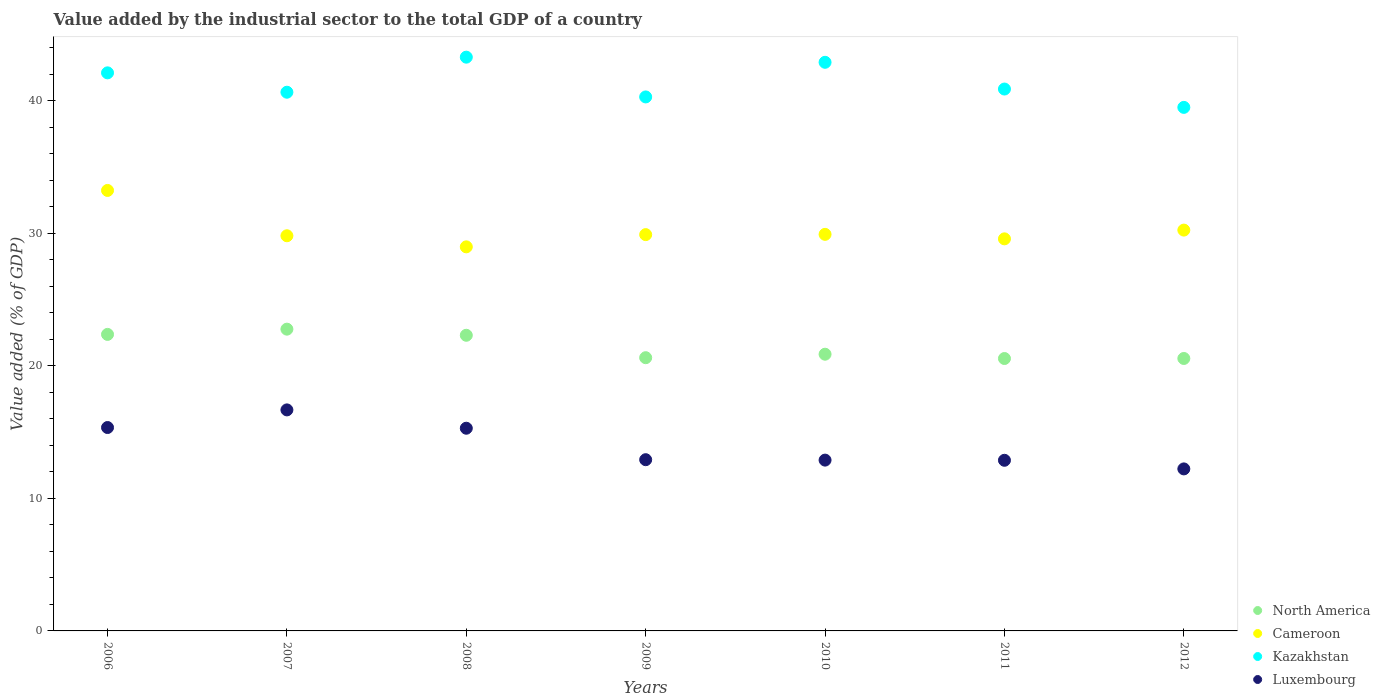How many different coloured dotlines are there?
Offer a very short reply. 4. What is the value added by the industrial sector to the total GDP in North America in 2011?
Your answer should be compact. 20.55. Across all years, what is the maximum value added by the industrial sector to the total GDP in North America?
Your answer should be compact. 22.76. Across all years, what is the minimum value added by the industrial sector to the total GDP in Kazakhstan?
Provide a succinct answer. 39.5. What is the total value added by the industrial sector to the total GDP in Luxembourg in the graph?
Offer a terse response. 98.21. What is the difference between the value added by the industrial sector to the total GDP in Cameroon in 2006 and that in 2009?
Provide a succinct answer. 3.33. What is the difference between the value added by the industrial sector to the total GDP in Cameroon in 2010 and the value added by the industrial sector to the total GDP in North America in 2012?
Your answer should be compact. 9.36. What is the average value added by the industrial sector to the total GDP in Cameroon per year?
Offer a terse response. 30.23. In the year 2009, what is the difference between the value added by the industrial sector to the total GDP in Luxembourg and value added by the industrial sector to the total GDP in North America?
Offer a terse response. -7.69. In how many years, is the value added by the industrial sector to the total GDP in Cameroon greater than 22 %?
Offer a terse response. 7. What is the ratio of the value added by the industrial sector to the total GDP in Kazakhstan in 2009 to that in 2011?
Your answer should be very brief. 0.99. Is the value added by the industrial sector to the total GDP in North America in 2010 less than that in 2012?
Offer a terse response. No. What is the difference between the highest and the second highest value added by the industrial sector to the total GDP in North America?
Provide a short and direct response. 0.4. What is the difference between the highest and the lowest value added by the industrial sector to the total GDP in Kazakhstan?
Provide a short and direct response. 3.79. In how many years, is the value added by the industrial sector to the total GDP in Kazakhstan greater than the average value added by the industrial sector to the total GDP in Kazakhstan taken over all years?
Ensure brevity in your answer.  3. Is the sum of the value added by the industrial sector to the total GDP in Luxembourg in 2008 and 2011 greater than the maximum value added by the industrial sector to the total GDP in Kazakhstan across all years?
Offer a terse response. No. Is the value added by the industrial sector to the total GDP in North America strictly less than the value added by the industrial sector to the total GDP in Cameroon over the years?
Keep it short and to the point. Yes. What is the difference between two consecutive major ticks on the Y-axis?
Offer a terse response. 10. Does the graph contain any zero values?
Keep it short and to the point. No. Does the graph contain grids?
Ensure brevity in your answer.  No. How many legend labels are there?
Your answer should be compact. 4. How are the legend labels stacked?
Ensure brevity in your answer.  Vertical. What is the title of the graph?
Your answer should be very brief. Value added by the industrial sector to the total GDP of a country. What is the label or title of the X-axis?
Keep it short and to the point. Years. What is the label or title of the Y-axis?
Make the answer very short. Value added (% of GDP). What is the Value added (% of GDP) of North America in 2006?
Make the answer very short. 22.37. What is the Value added (% of GDP) in Cameroon in 2006?
Your answer should be very brief. 33.23. What is the Value added (% of GDP) in Kazakhstan in 2006?
Provide a succinct answer. 42.1. What is the Value added (% of GDP) in Luxembourg in 2006?
Ensure brevity in your answer.  15.34. What is the Value added (% of GDP) in North America in 2007?
Your answer should be compact. 22.76. What is the Value added (% of GDP) of Cameroon in 2007?
Give a very brief answer. 29.81. What is the Value added (% of GDP) of Kazakhstan in 2007?
Keep it short and to the point. 40.64. What is the Value added (% of GDP) of Luxembourg in 2007?
Your answer should be very brief. 16.67. What is the Value added (% of GDP) in North America in 2008?
Provide a short and direct response. 22.3. What is the Value added (% of GDP) in Cameroon in 2008?
Your response must be concise. 28.97. What is the Value added (% of GDP) of Kazakhstan in 2008?
Provide a succinct answer. 43.28. What is the Value added (% of GDP) in Luxembourg in 2008?
Make the answer very short. 15.29. What is the Value added (% of GDP) of North America in 2009?
Offer a very short reply. 20.61. What is the Value added (% of GDP) of Cameroon in 2009?
Offer a very short reply. 29.9. What is the Value added (% of GDP) of Kazakhstan in 2009?
Offer a very short reply. 40.28. What is the Value added (% of GDP) in Luxembourg in 2009?
Offer a terse response. 12.92. What is the Value added (% of GDP) of North America in 2010?
Your answer should be very brief. 20.88. What is the Value added (% of GDP) in Cameroon in 2010?
Offer a very short reply. 29.92. What is the Value added (% of GDP) of Kazakhstan in 2010?
Your response must be concise. 42.9. What is the Value added (% of GDP) in Luxembourg in 2010?
Keep it short and to the point. 12.89. What is the Value added (% of GDP) of North America in 2011?
Provide a short and direct response. 20.55. What is the Value added (% of GDP) of Cameroon in 2011?
Your answer should be very brief. 29.58. What is the Value added (% of GDP) of Kazakhstan in 2011?
Your answer should be very brief. 40.88. What is the Value added (% of GDP) in Luxembourg in 2011?
Keep it short and to the point. 12.87. What is the Value added (% of GDP) in North America in 2012?
Ensure brevity in your answer.  20.55. What is the Value added (% of GDP) of Cameroon in 2012?
Provide a short and direct response. 30.24. What is the Value added (% of GDP) in Kazakhstan in 2012?
Provide a short and direct response. 39.5. What is the Value added (% of GDP) in Luxembourg in 2012?
Make the answer very short. 12.22. Across all years, what is the maximum Value added (% of GDP) of North America?
Offer a terse response. 22.76. Across all years, what is the maximum Value added (% of GDP) of Cameroon?
Ensure brevity in your answer.  33.23. Across all years, what is the maximum Value added (% of GDP) in Kazakhstan?
Ensure brevity in your answer.  43.28. Across all years, what is the maximum Value added (% of GDP) of Luxembourg?
Give a very brief answer. 16.67. Across all years, what is the minimum Value added (% of GDP) of North America?
Provide a succinct answer. 20.55. Across all years, what is the minimum Value added (% of GDP) in Cameroon?
Provide a succinct answer. 28.97. Across all years, what is the minimum Value added (% of GDP) in Kazakhstan?
Offer a terse response. 39.5. Across all years, what is the minimum Value added (% of GDP) in Luxembourg?
Your response must be concise. 12.22. What is the total Value added (% of GDP) of North America in the graph?
Your answer should be compact. 150.03. What is the total Value added (% of GDP) of Cameroon in the graph?
Offer a very short reply. 211.64. What is the total Value added (% of GDP) of Kazakhstan in the graph?
Your answer should be very brief. 289.58. What is the total Value added (% of GDP) in Luxembourg in the graph?
Make the answer very short. 98.21. What is the difference between the Value added (% of GDP) in North America in 2006 and that in 2007?
Offer a terse response. -0.4. What is the difference between the Value added (% of GDP) of Cameroon in 2006 and that in 2007?
Give a very brief answer. 3.42. What is the difference between the Value added (% of GDP) of Kazakhstan in 2006 and that in 2007?
Give a very brief answer. 1.46. What is the difference between the Value added (% of GDP) of Luxembourg in 2006 and that in 2007?
Provide a short and direct response. -1.33. What is the difference between the Value added (% of GDP) in North America in 2006 and that in 2008?
Offer a very short reply. 0.07. What is the difference between the Value added (% of GDP) of Cameroon in 2006 and that in 2008?
Your answer should be compact. 4.26. What is the difference between the Value added (% of GDP) in Kazakhstan in 2006 and that in 2008?
Make the answer very short. -1.18. What is the difference between the Value added (% of GDP) of Luxembourg in 2006 and that in 2008?
Keep it short and to the point. 0.05. What is the difference between the Value added (% of GDP) in North America in 2006 and that in 2009?
Your answer should be compact. 1.76. What is the difference between the Value added (% of GDP) of Cameroon in 2006 and that in 2009?
Offer a terse response. 3.33. What is the difference between the Value added (% of GDP) in Kazakhstan in 2006 and that in 2009?
Offer a very short reply. 1.82. What is the difference between the Value added (% of GDP) in Luxembourg in 2006 and that in 2009?
Provide a short and direct response. 2.43. What is the difference between the Value added (% of GDP) in North America in 2006 and that in 2010?
Provide a succinct answer. 1.49. What is the difference between the Value added (% of GDP) of Cameroon in 2006 and that in 2010?
Offer a very short reply. 3.31. What is the difference between the Value added (% of GDP) in Kazakhstan in 2006 and that in 2010?
Offer a terse response. -0.8. What is the difference between the Value added (% of GDP) in Luxembourg in 2006 and that in 2010?
Offer a terse response. 2.46. What is the difference between the Value added (% of GDP) in North America in 2006 and that in 2011?
Provide a short and direct response. 1.82. What is the difference between the Value added (% of GDP) of Cameroon in 2006 and that in 2011?
Offer a very short reply. 3.65. What is the difference between the Value added (% of GDP) in Kazakhstan in 2006 and that in 2011?
Offer a very short reply. 1.22. What is the difference between the Value added (% of GDP) of Luxembourg in 2006 and that in 2011?
Give a very brief answer. 2.47. What is the difference between the Value added (% of GDP) in North America in 2006 and that in 2012?
Your answer should be compact. 1.82. What is the difference between the Value added (% of GDP) of Cameroon in 2006 and that in 2012?
Give a very brief answer. 2.99. What is the difference between the Value added (% of GDP) in Kazakhstan in 2006 and that in 2012?
Your response must be concise. 2.6. What is the difference between the Value added (% of GDP) of Luxembourg in 2006 and that in 2012?
Make the answer very short. 3.12. What is the difference between the Value added (% of GDP) in North America in 2007 and that in 2008?
Provide a succinct answer. 0.46. What is the difference between the Value added (% of GDP) of Cameroon in 2007 and that in 2008?
Offer a very short reply. 0.84. What is the difference between the Value added (% of GDP) of Kazakhstan in 2007 and that in 2008?
Your answer should be compact. -2.65. What is the difference between the Value added (% of GDP) of Luxembourg in 2007 and that in 2008?
Provide a short and direct response. 1.38. What is the difference between the Value added (% of GDP) of North America in 2007 and that in 2009?
Your answer should be compact. 2.15. What is the difference between the Value added (% of GDP) of Cameroon in 2007 and that in 2009?
Provide a short and direct response. -0.09. What is the difference between the Value added (% of GDP) of Kazakhstan in 2007 and that in 2009?
Provide a succinct answer. 0.35. What is the difference between the Value added (% of GDP) in Luxembourg in 2007 and that in 2009?
Keep it short and to the point. 3.76. What is the difference between the Value added (% of GDP) in North America in 2007 and that in 2010?
Your answer should be compact. 1.89. What is the difference between the Value added (% of GDP) of Cameroon in 2007 and that in 2010?
Your response must be concise. -0.11. What is the difference between the Value added (% of GDP) of Kazakhstan in 2007 and that in 2010?
Provide a succinct answer. -2.26. What is the difference between the Value added (% of GDP) in Luxembourg in 2007 and that in 2010?
Make the answer very short. 3.79. What is the difference between the Value added (% of GDP) in North America in 2007 and that in 2011?
Offer a very short reply. 2.21. What is the difference between the Value added (% of GDP) of Cameroon in 2007 and that in 2011?
Offer a terse response. 0.23. What is the difference between the Value added (% of GDP) of Kazakhstan in 2007 and that in 2011?
Your answer should be compact. -0.24. What is the difference between the Value added (% of GDP) of Luxembourg in 2007 and that in 2011?
Provide a short and direct response. 3.8. What is the difference between the Value added (% of GDP) in North America in 2007 and that in 2012?
Offer a very short reply. 2.21. What is the difference between the Value added (% of GDP) in Cameroon in 2007 and that in 2012?
Offer a terse response. -0.43. What is the difference between the Value added (% of GDP) of Kazakhstan in 2007 and that in 2012?
Ensure brevity in your answer.  1.14. What is the difference between the Value added (% of GDP) of Luxembourg in 2007 and that in 2012?
Your answer should be compact. 4.45. What is the difference between the Value added (% of GDP) of North America in 2008 and that in 2009?
Keep it short and to the point. 1.69. What is the difference between the Value added (% of GDP) of Cameroon in 2008 and that in 2009?
Offer a terse response. -0.92. What is the difference between the Value added (% of GDP) of Kazakhstan in 2008 and that in 2009?
Offer a terse response. 3. What is the difference between the Value added (% of GDP) in Luxembourg in 2008 and that in 2009?
Give a very brief answer. 2.37. What is the difference between the Value added (% of GDP) in North America in 2008 and that in 2010?
Your response must be concise. 1.43. What is the difference between the Value added (% of GDP) in Cameroon in 2008 and that in 2010?
Your answer should be compact. -0.94. What is the difference between the Value added (% of GDP) of Kazakhstan in 2008 and that in 2010?
Provide a short and direct response. 0.39. What is the difference between the Value added (% of GDP) of Luxembourg in 2008 and that in 2010?
Provide a short and direct response. 2.41. What is the difference between the Value added (% of GDP) of North America in 2008 and that in 2011?
Provide a short and direct response. 1.75. What is the difference between the Value added (% of GDP) in Cameroon in 2008 and that in 2011?
Keep it short and to the point. -0.6. What is the difference between the Value added (% of GDP) in Kazakhstan in 2008 and that in 2011?
Ensure brevity in your answer.  2.4. What is the difference between the Value added (% of GDP) of Luxembourg in 2008 and that in 2011?
Offer a very short reply. 2.42. What is the difference between the Value added (% of GDP) in North America in 2008 and that in 2012?
Make the answer very short. 1.75. What is the difference between the Value added (% of GDP) in Cameroon in 2008 and that in 2012?
Your answer should be very brief. -1.26. What is the difference between the Value added (% of GDP) in Kazakhstan in 2008 and that in 2012?
Provide a succinct answer. 3.79. What is the difference between the Value added (% of GDP) of Luxembourg in 2008 and that in 2012?
Ensure brevity in your answer.  3.07. What is the difference between the Value added (% of GDP) in North America in 2009 and that in 2010?
Make the answer very short. -0.26. What is the difference between the Value added (% of GDP) of Cameroon in 2009 and that in 2010?
Keep it short and to the point. -0.02. What is the difference between the Value added (% of GDP) in Kazakhstan in 2009 and that in 2010?
Provide a succinct answer. -2.61. What is the difference between the Value added (% of GDP) in Luxembourg in 2009 and that in 2010?
Offer a terse response. 0.03. What is the difference between the Value added (% of GDP) in North America in 2009 and that in 2011?
Offer a terse response. 0.06. What is the difference between the Value added (% of GDP) of Cameroon in 2009 and that in 2011?
Provide a succinct answer. 0.32. What is the difference between the Value added (% of GDP) in Kazakhstan in 2009 and that in 2011?
Your response must be concise. -0.59. What is the difference between the Value added (% of GDP) in Luxembourg in 2009 and that in 2011?
Your answer should be compact. 0.04. What is the difference between the Value added (% of GDP) in North America in 2009 and that in 2012?
Ensure brevity in your answer.  0.06. What is the difference between the Value added (% of GDP) of Cameroon in 2009 and that in 2012?
Make the answer very short. -0.34. What is the difference between the Value added (% of GDP) of Kazakhstan in 2009 and that in 2012?
Provide a short and direct response. 0.79. What is the difference between the Value added (% of GDP) of Luxembourg in 2009 and that in 2012?
Make the answer very short. 0.69. What is the difference between the Value added (% of GDP) in North America in 2010 and that in 2011?
Provide a short and direct response. 0.33. What is the difference between the Value added (% of GDP) of Cameroon in 2010 and that in 2011?
Ensure brevity in your answer.  0.34. What is the difference between the Value added (% of GDP) in Kazakhstan in 2010 and that in 2011?
Offer a terse response. 2.02. What is the difference between the Value added (% of GDP) in Luxembourg in 2010 and that in 2011?
Provide a succinct answer. 0.01. What is the difference between the Value added (% of GDP) of North America in 2010 and that in 2012?
Offer a terse response. 0.32. What is the difference between the Value added (% of GDP) in Cameroon in 2010 and that in 2012?
Ensure brevity in your answer.  -0.32. What is the difference between the Value added (% of GDP) of Kazakhstan in 2010 and that in 2012?
Your response must be concise. 3.4. What is the difference between the Value added (% of GDP) of Luxembourg in 2010 and that in 2012?
Offer a very short reply. 0.66. What is the difference between the Value added (% of GDP) of North America in 2011 and that in 2012?
Your response must be concise. -0. What is the difference between the Value added (% of GDP) in Cameroon in 2011 and that in 2012?
Provide a short and direct response. -0.66. What is the difference between the Value added (% of GDP) of Kazakhstan in 2011 and that in 2012?
Your answer should be very brief. 1.38. What is the difference between the Value added (% of GDP) of Luxembourg in 2011 and that in 2012?
Your answer should be very brief. 0.65. What is the difference between the Value added (% of GDP) of North America in 2006 and the Value added (% of GDP) of Cameroon in 2007?
Provide a succinct answer. -7.44. What is the difference between the Value added (% of GDP) of North America in 2006 and the Value added (% of GDP) of Kazakhstan in 2007?
Your response must be concise. -18.27. What is the difference between the Value added (% of GDP) in North America in 2006 and the Value added (% of GDP) in Luxembourg in 2007?
Your answer should be compact. 5.7. What is the difference between the Value added (% of GDP) of Cameroon in 2006 and the Value added (% of GDP) of Kazakhstan in 2007?
Keep it short and to the point. -7.41. What is the difference between the Value added (% of GDP) of Cameroon in 2006 and the Value added (% of GDP) of Luxembourg in 2007?
Your answer should be very brief. 16.56. What is the difference between the Value added (% of GDP) in Kazakhstan in 2006 and the Value added (% of GDP) in Luxembourg in 2007?
Ensure brevity in your answer.  25.43. What is the difference between the Value added (% of GDP) in North America in 2006 and the Value added (% of GDP) in Cameroon in 2008?
Make the answer very short. -6.6. What is the difference between the Value added (% of GDP) in North America in 2006 and the Value added (% of GDP) in Kazakhstan in 2008?
Ensure brevity in your answer.  -20.91. What is the difference between the Value added (% of GDP) of North America in 2006 and the Value added (% of GDP) of Luxembourg in 2008?
Your answer should be compact. 7.08. What is the difference between the Value added (% of GDP) of Cameroon in 2006 and the Value added (% of GDP) of Kazakhstan in 2008?
Give a very brief answer. -10.05. What is the difference between the Value added (% of GDP) in Cameroon in 2006 and the Value added (% of GDP) in Luxembourg in 2008?
Provide a succinct answer. 17.94. What is the difference between the Value added (% of GDP) of Kazakhstan in 2006 and the Value added (% of GDP) of Luxembourg in 2008?
Give a very brief answer. 26.81. What is the difference between the Value added (% of GDP) in North America in 2006 and the Value added (% of GDP) in Cameroon in 2009?
Provide a succinct answer. -7.53. What is the difference between the Value added (% of GDP) in North America in 2006 and the Value added (% of GDP) in Kazakhstan in 2009?
Give a very brief answer. -17.91. What is the difference between the Value added (% of GDP) in North America in 2006 and the Value added (% of GDP) in Luxembourg in 2009?
Offer a very short reply. 9.45. What is the difference between the Value added (% of GDP) of Cameroon in 2006 and the Value added (% of GDP) of Kazakhstan in 2009?
Give a very brief answer. -7.05. What is the difference between the Value added (% of GDP) of Cameroon in 2006 and the Value added (% of GDP) of Luxembourg in 2009?
Provide a succinct answer. 20.31. What is the difference between the Value added (% of GDP) in Kazakhstan in 2006 and the Value added (% of GDP) in Luxembourg in 2009?
Ensure brevity in your answer.  29.18. What is the difference between the Value added (% of GDP) of North America in 2006 and the Value added (% of GDP) of Cameroon in 2010?
Your answer should be very brief. -7.55. What is the difference between the Value added (% of GDP) in North America in 2006 and the Value added (% of GDP) in Kazakhstan in 2010?
Give a very brief answer. -20.53. What is the difference between the Value added (% of GDP) of North America in 2006 and the Value added (% of GDP) of Luxembourg in 2010?
Your response must be concise. 9.48. What is the difference between the Value added (% of GDP) of Cameroon in 2006 and the Value added (% of GDP) of Kazakhstan in 2010?
Make the answer very short. -9.67. What is the difference between the Value added (% of GDP) of Cameroon in 2006 and the Value added (% of GDP) of Luxembourg in 2010?
Ensure brevity in your answer.  20.34. What is the difference between the Value added (% of GDP) of Kazakhstan in 2006 and the Value added (% of GDP) of Luxembourg in 2010?
Keep it short and to the point. 29.22. What is the difference between the Value added (% of GDP) in North America in 2006 and the Value added (% of GDP) in Cameroon in 2011?
Give a very brief answer. -7.21. What is the difference between the Value added (% of GDP) of North America in 2006 and the Value added (% of GDP) of Kazakhstan in 2011?
Your answer should be very brief. -18.51. What is the difference between the Value added (% of GDP) of North America in 2006 and the Value added (% of GDP) of Luxembourg in 2011?
Your answer should be compact. 9.5. What is the difference between the Value added (% of GDP) of Cameroon in 2006 and the Value added (% of GDP) of Kazakhstan in 2011?
Your answer should be very brief. -7.65. What is the difference between the Value added (% of GDP) of Cameroon in 2006 and the Value added (% of GDP) of Luxembourg in 2011?
Your answer should be very brief. 20.36. What is the difference between the Value added (% of GDP) of Kazakhstan in 2006 and the Value added (% of GDP) of Luxembourg in 2011?
Your response must be concise. 29.23. What is the difference between the Value added (% of GDP) of North America in 2006 and the Value added (% of GDP) of Cameroon in 2012?
Your response must be concise. -7.87. What is the difference between the Value added (% of GDP) of North America in 2006 and the Value added (% of GDP) of Kazakhstan in 2012?
Make the answer very short. -17.13. What is the difference between the Value added (% of GDP) of North America in 2006 and the Value added (% of GDP) of Luxembourg in 2012?
Make the answer very short. 10.15. What is the difference between the Value added (% of GDP) of Cameroon in 2006 and the Value added (% of GDP) of Kazakhstan in 2012?
Your answer should be compact. -6.27. What is the difference between the Value added (% of GDP) in Cameroon in 2006 and the Value added (% of GDP) in Luxembourg in 2012?
Give a very brief answer. 21.01. What is the difference between the Value added (% of GDP) in Kazakhstan in 2006 and the Value added (% of GDP) in Luxembourg in 2012?
Your answer should be compact. 29.88. What is the difference between the Value added (% of GDP) of North America in 2007 and the Value added (% of GDP) of Cameroon in 2008?
Your answer should be compact. -6.21. What is the difference between the Value added (% of GDP) of North America in 2007 and the Value added (% of GDP) of Kazakhstan in 2008?
Ensure brevity in your answer.  -20.52. What is the difference between the Value added (% of GDP) in North America in 2007 and the Value added (% of GDP) in Luxembourg in 2008?
Provide a short and direct response. 7.47. What is the difference between the Value added (% of GDP) in Cameroon in 2007 and the Value added (% of GDP) in Kazakhstan in 2008?
Provide a succinct answer. -13.47. What is the difference between the Value added (% of GDP) of Cameroon in 2007 and the Value added (% of GDP) of Luxembourg in 2008?
Your response must be concise. 14.52. What is the difference between the Value added (% of GDP) of Kazakhstan in 2007 and the Value added (% of GDP) of Luxembourg in 2008?
Provide a succinct answer. 25.35. What is the difference between the Value added (% of GDP) in North America in 2007 and the Value added (% of GDP) in Cameroon in 2009?
Provide a short and direct response. -7.13. What is the difference between the Value added (% of GDP) of North America in 2007 and the Value added (% of GDP) of Kazakhstan in 2009?
Your answer should be very brief. -17.52. What is the difference between the Value added (% of GDP) of North America in 2007 and the Value added (% of GDP) of Luxembourg in 2009?
Provide a succinct answer. 9.85. What is the difference between the Value added (% of GDP) in Cameroon in 2007 and the Value added (% of GDP) in Kazakhstan in 2009?
Your answer should be compact. -10.47. What is the difference between the Value added (% of GDP) in Cameroon in 2007 and the Value added (% of GDP) in Luxembourg in 2009?
Your response must be concise. 16.89. What is the difference between the Value added (% of GDP) in Kazakhstan in 2007 and the Value added (% of GDP) in Luxembourg in 2009?
Your answer should be compact. 27.72. What is the difference between the Value added (% of GDP) in North America in 2007 and the Value added (% of GDP) in Cameroon in 2010?
Keep it short and to the point. -7.15. What is the difference between the Value added (% of GDP) of North America in 2007 and the Value added (% of GDP) of Kazakhstan in 2010?
Your answer should be compact. -20.13. What is the difference between the Value added (% of GDP) of North America in 2007 and the Value added (% of GDP) of Luxembourg in 2010?
Your answer should be compact. 9.88. What is the difference between the Value added (% of GDP) in Cameroon in 2007 and the Value added (% of GDP) in Kazakhstan in 2010?
Provide a succinct answer. -13.09. What is the difference between the Value added (% of GDP) in Cameroon in 2007 and the Value added (% of GDP) in Luxembourg in 2010?
Offer a terse response. 16.93. What is the difference between the Value added (% of GDP) of Kazakhstan in 2007 and the Value added (% of GDP) of Luxembourg in 2010?
Keep it short and to the point. 27.75. What is the difference between the Value added (% of GDP) of North America in 2007 and the Value added (% of GDP) of Cameroon in 2011?
Offer a terse response. -6.81. What is the difference between the Value added (% of GDP) in North America in 2007 and the Value added (% of GDP) in Kazakhstan in 2011?
Make the answer very short. -18.11. What is the difference between the Value added (% of GDP) of North America in 2007 and the Value added (% of GDP) of Luxembourg in 2011?
Provide a succinct answer. 9.89. What is the difference between the Value added (% of GDP) of Cameroon in 2007 and the Value added (% of GDP) of Kazakhstan in 2011?
Your answer should be compact. -11.07. What is the difference between the Value added (% of GDP) of Cameroon in 2007 and the Value added (% of GDP) of Luxembourg in 2011?
Ensure brevity in your answer.  16.94. What is the difference between the Value added (% of GDP) in Kazakhstan in 2007 and the Value added (% of GDP) in Luxembourg in 2011?
Provide a succinct answer. 27.77. What is the difference between the Value added (% of GDP) of North America in 2007 and the Value added (% of GDP) of Cameroon in 2012?
Offer a very short reply. -7.47. What is the difference between the Value added (% of GDP) of North America in 2007 and the Value added (% of GDP) of Kazakhstan in 2012?
Your answer should be very brief. -16.73. What is the difference between the Value added (% of GDP) of North America in 2007 and the Value added (% of GDP) of Luxembourg in 2012?
Provide a short and direct response. 10.54. What is the difference between the Value added (% of GDP) of Cameroon in 2007 and the Value added (% of GDP) of Kazakhstan in 2012?
Your answer should be compact. -9.69. What is the difference between the Value added (% of GDP) of Cameroon in 2007 and the Value added (% of GDP) of Luxembourg in 2012?
Your answer should be very brief. 17.59. What is the difference between the Value added (% of GDP) of Kazakhstan in 2007 and the Value added (% of GDP) of Luxembourg in 2012?
Offer a terse response. 28.42. What is the difference between the Value added (% of GDP) of North America in 2008 and the Value added (% of GDP) of Cameroon in 2009?
Ensure brevity in your answer.  -7.59. What is the difference between the Value added (% of GDP) in North America in 2008 and the Value added (% of GDP) in Kazakhstan in 2009?
Provide a succinct answer. -17.98. What is the difference between the Value added (% of GDP) of North America in 2008 and the Value added (% of GDP) of Luxembourg in 2009?
Your answer should be very brief. 9.39. What is the difference between the Value added (% of GDP) of Cameroon in 2008 and the Value added (% of GDP) of Kazakhstan in 2009?
Your answer should be compact. -11.31. What is the difference between the Value added (% of GDP) in Cameroon in 2008 and the Value added (% of GDP) in Luxembourg in 2009?
Your answer should be very brief. 16.06. What is the difference between the Value added (% of GDP) of Kazakhstan in 2008 and the Value added (% of GDP) of Luxembourg in 2009?
Provide a short and direct response. 30.37. What is the difference between the Value added (% of GDP) in North America in 2008 and the Value added (% of GDP) in Cameroon in 2010?
Keep it short and to the point. -7.61. What is the difference between the Value added (% of GDP) in North America in 2008 and the Value added (% of GDP) in Kazakhstan in 2010?
Provide a short and direct response. -20.59. What is the difference between the Value added (% of GDP) in North America in 2008 and the Value added (% of GDP) in Luxembourg in 2010?
Keep it short and to the point. 9.42. What is the difference between the Value added (% of GDP) of Cameroon in 2008 and the Value added (% of GDP) of Kazakhstan in 2010?
Offer a terse response. -13.92. What is the difference between the Value added (% of GDP) in Cameroon in 2008 and the Value added (% of GDP) in Luxembourg in 2010?
Your response must be concise. 16.09. What is the difference between the Value added (% of GDP) in Kazakhstan in 2008 and the Value added (% of GDP) in Luxembourg in 2010?
Ensure brevity in your answer.  30.4. What is the difference between the Value added (% of GDP) of North America in 2008 and the Value added (% of GDP) of Cameroon in 2011?
Give a very brief answer. -7.27. What is the difference between the Value added (% of GDP) of North America in 2008 and the Value added (% of GDP) of Kazakhstan in 2011?
Provide a short and direct response. -18.58. What is the difference between the Value added (% of GDP) of North America in 2008 and the Value added (% of GDP) of Luxembourg in 2011?
Provide a short and direct response. 9.43. What is the difference between the Value added (% of GDP) in Cameroon in 2008 and the Value added (% of GDP) in Kazakhstan in 2011?
Your answer should be compact. -11.9. What is the difference between the Value added (% of GDP) in Cameroon in 2008 and the Value added (% of GDP) in Luxembourg in 2011?
Your answer should be compact. 16.1. What is the difference between the Value added (% of GDP) of Kazakhstan in 2008 and the Value added (% of GDP) of Luxembourg in 2011?
Your answer should be compact. 30.41. What is the difference between the Value added (% of GDP) in North America in 2008 and the Value added (% of GDP) in Cameroon in 2012?
Give a very brief answer. -7.93. What is the difference between the Value added (% of GDP) of North America in 2008 and the Value added (% of GDP) of Kazakhstan in 2012?
Provide a short and direct response. -17.19. What is the difference between the Value added (% of GDP) of North America in 2008 and the Value added (% of GDP) of Luxembourg in 2012?
Your answer should be very brief. 10.08. What is the difference between the Value added (% of GDP) in Cameroon in 2008 and the Value added (% of GDP) in Kazakhstan in 2012?
Provide a succinct answer. -10.52. What is the difference between the Value added (% of GDP) of Cameroon in 2008 and the Value added (% of GDP) of Luxembourg in 2012?
Your answer should be very brief. 16.75. What is the difference between the Value added (% of GDP) of Kazakhstan in 2008 and the Value added (% of GDP) of Luxembourg in 2012?
Your response must be concise. 31.06. What is the difference between the Value added (% of GDP) of North America in 2009 and the Value added (% of GDP) of Cameroon in 2010?
Make the answer very short. -9.3. What is the difference between the Value added (% of GDP) of North America in 2009 and the Value added (% of GDP) of Kazakhstan in 2010?
Ensure brevity in your answer.  -22.28. What is the difference between the Value added (% of GDP) of North America in 2009 and the Value added (% of GDP) of Luxembourg in 2010?
Make the answer very short. 7.73. What is the difference between the Value added (% of GDP) in Cameroon in 2009 and the Value added (% of GDP) in Kazakhstan in 2010?
Keep it short and to the point. -13. What is the difference between the Value added (% of GDP) of Cameroon in 2009 and the Value added (% of GDP) of Luxembourg in 2010?
Offer a terse response. 17.01. What is the difference between the Value added (% of GDP) of Kazakhstan in 2009 and the Value added (% of GDP) of Luxembourg in 2010?
Keep it short and to the point. 27.4. What is the difference between the Value added (% of GDP) of North America in 2009 and the Value added (% of GDP) of Cameroon in 2011?
Your response must be concise. -8.97. What is the difference between the Value added (% of GDP) in North America in 2009 and the Value added (% of GDP) in Kazakhstan in 2011?
Keep it short and to the point. -20.27. What is the difference between the Value added (% of GDP) in North America in 2009 and the Value added (% of GDP) in Luxembourg in 2011?
Give a very brief answer. 7.74. What is the difference between the Value added (% of GDP) in Cameroon in 2009 and the Value added (% of GDP) in Kazakhstan in 2011?
Make the answer very short. -10.98. What is the difference between the Value added (% of GDP) of Cameroon in 2009 and the Value added (% of GDP) of Luxembourg in 2011?
Your answer should be compact. 17.02. What is the difference between the Value added (% of GDP) of Kazakhstan in 2009 and the Value added (% of GDP) of Luxembourg in 2011?
Your answer should be compact. 27.41. What is the difference between the Value added (% of GDP) in North America in 2009 and the Value added (% of GDP) in Cameroon in 2012?
Provide a short and direct response. -9.63. What is the difference between the Value added (% of GDP) in North America in 2009 and the Value added (% of GDP) in Kazakhstan in 2012?
Provide a short and direct response. -18.88. What is the difference between the Value added (% of GDP) in North America in 2009 and the Value added (% of GDP) in Luxembourg in 2012?
Your answer should be very brief. 8.39. What is the difference between the Value added (% of GDP) of Cameroon in 2009 and the Value added (% of GDP) of Kazakhstan in 2012?
Offer a very short reply. -9.6. What is the difference between the Value added (% of GDP) of Cameroon in 2009 and the Value added (% of GDP) of Luxembourg in 2012?
Give a very brief answer. 17.67. What is the difference between the Value added (% of GDP) in Kazakhstan in 2009 and the Value added (% of GDP) in Luxembourg in 2012?
Ensure brevity in your answer.  28.06. What is the difference between the Value added (% of GDP) in North America in 2010 and the Value added (% of GDP) in Cameroon in 2011?
Provide a short and direct response. -8.7. What is the difference between the Value added (% of GDP) of North America in 2010 and the Value added (% of GDP) of Kazakhstan in 2011?
Your answer should be very brief. -20. What is the difference between the Value added (% of GDP) in North America in 2010 and the Value added (% of GDP) in Luxembourg in 2011?
Provide a succinct answer. 8. What is the difference between the Value added (% of GDP) in Cameroon in 2010 and the Value added (% of GDP) in Kazakhstan in 2011?
Offer a terse response. -10.96. What is the difference between the Value added (% of GDP) of Cameroon in 2010 and the Value added (% of GDP) of Luxembourg in 2011?
Ensure brevity in your answer.  17.04. What is the difference between the Value added (% of GDP) of Kazakhstan in 2010 and the Value added (% of GDP) of Luxembourg in 2011?
Offer a terse response. 30.02. What is the difference between the Value added (% of GDP) in North America in 2010 and the Value added (% of GDP) in Cameroon in 2012?
Offer a very short reply. -9.36. What is the difference between the Value added (% of GDP) in North America in 2010 and the Value added (% of GDP) in Kazakhstan in 2012?
Ensure brevity in your answer.  -18.62. What is the difference between the Value added (% of GDP) of North America in 2010 and the Value added (% of GDP) of Luxembourg in 2012?
Provide a succinct answer. 8.65. What is the difference between the Value added (% of GDP) of Cameroon in 2010 and the Value added (% of GDP) of Kazakhstan in 2012?
Offer a very short reply. -9.58. What is the difference between the Value added (% of GDP) of Cameroon in 2010 and the Value added (% of GDP) of Luxembourg in 2012?
Give a very brief answer. 17.69. What is the difference between the Value added (% of GDP) of Kazakhstan in 2010 and the Value added (% of GDP) of Luxembourg in 2012?
Keep it short and to the point. 30.67. What is the difference between the Value added (% of GDP) in North America in 2011 and the Value added (% of GDP) in Cameroon in 2012?
Your response must be concise. -9.69. What is the difference between the Value added (% of GDP) in North America in 2011 and the Value added (% of GDP) in Kazakhstan in 2012?
Your answer should be very brief. -18.95. What is the difference between the Value added (% of GDP) of North America in 2011 and the Value added (% of GDP) of Luxembourg in 2012?
Your response must be concise. 8.33. What is the difference between the Value added (% of GDP) of Cameroon in 2011 and the Value added (% of GDP) of Kazakhstan in 2012?
Your response must be concise. -9.92. What is the difference between the Value added (% of GDP) of Cameroon in 2011 and the Value added (% of GDP) of Luxembourg in 2012?
Give a very brief answer. 17.35. What is the difference between the Value added (% of GDP) in Kazakhstan in 2011 and the Value added (% of GDP) in Luxembourg in 2012?
Offer a terse response. 28.66. What is the average Value added (% of GDP) in North America per year?
Offer a terse response. 21.43. What is the average Value added (% of GDP) in Cameroon per year?
Provide a short and direct response. 30.23. What is the average Value added (% of GDP) of Kazakhstan per year?
Offer a very short reply. 41.37. What is the average Value added (% of GDP) in Luxembourg per year?
Offer a very short reply. 14.03. In the year 2006, what is the difference between the Value added (% of GDP) of North America and Value added (% of GDP) of Cameroon?
Make the answer very short. -10.86. In the year 2006, what is the difference between the Value added (% of GDP) in North America and Value added (% of GDP) in Kazakhstan?
Your response must be concise. -19.73. In the year 2006, what is the difference between the Value added (% of GDP) in North America and Value added (% of GDP) in Luxembourg?
Your response must be concise. 7.03. In the year 2006, what is the difference between the Value added (% of GDP) in Cameroon and Value added (% of GDP) in Kazakhstan?
Your response must be concise. -8.87. In the year 2006, what is the difference between the Value added (% of GDP) of Cameroon and Value added (% of GDP) of Luxembourg?
Provide a short and direct response. 17.89. In the year 2006, what is the difference between the Value added (% of GDP) of Kazakhstan and Value added (% of GDP) of Luxembourg?
Provide a succinct answer. 26.76. In the year 2007, what is the difference between the Value added (% of GDP) in North America and Value added (% of GDP) in Cameroon?
Your answer should be compact. -7.05. In the year 2007, what is the difference between the Value added (% of GDP) of North America and Value added (% of GDP) of Kazakhstan?
Make the answer very short. -17.87. In the year 2007, what is the difference between the Value added (% of GDP) in North America and Value added (% of GDP) in Luxembourg?
Keep it short and to the point. 6.09. In the year 2007, what is the difference between the Value added (% of GDP) in Cameroon and Value added (% of GDP) in Kazakhstan?
Keep it short and to the point. -10.83. In the year 2007, what is the difference between the Value added (% of GDP) in Cameroon and Value added (% of GDP) in Luxembourg?
Your answer should be compact. 13.14. In the year 2007, what is the difference between the Value added (% of GDP) of Kazakhstan and Value added (% of GDP) of Luxembourg?
Your response must be concise. 23.96. In the year 2008, what is the difference between the Value added (% of GDP) in North America and Value added (% of GDP) in Cameroon?
Your answer should be very brief. -6.67. In the year 2008, what is the difference between the Value added (% of GDP) of North America and Value added (% of GDP) of Kazakhstan?
Offer a terse response. -20.98. In the year 2008, what is the difference between the Value added (% of GDP) in North America and Value added (% of GDP) in Luxembourg?
Ensure brevity in your answer.  7.01. In the year 2008, what is the difference between the Value added (% of GDP) in Cameroon and Value added (% of GDP) in Kazakhstan?
Provide a short and direct response. -14.31. In the year 2008, what is the difference between the Value added (% of GDP) in Cameroon and Value added (% of GDP) in Luxembourg?
Provide a short and direct response. 13.68. In the year 2008, what is the difference between the Value added (% of GDP) of Kazakhstan and Value added (% of GDP) of Luxembourg?
Your answer should be very brief. 27.99. In the year 2009, what is the difference between the Value added (% of GDP) of North America and Value added (% of GDP) of Cameroon?
Your response must be concise. -9.28. In the year 2009, what is the difference between the Value added (% of GDP) in North America and Value added (% of GDP) in Kazakhstan?
Your answer should be compact. -19.67. In the year 2009, what is the difference between the Value added (% of GDP) in North America and Value added (% of GDP) in Luxembourg?
Your response must be concise. 7.69. In the year 2009, what is the difference between the Value added (% of GDP) in Cameroon and Value added (% of GDP) in Kazakhstan?
Your answer should be very brief. -10.39. In the year 2009, what is the difference between the Value added (% of GDP) in Cameroon and Value added (% of GDP) in Luxembourg?
Keep it short and to the point. 16.98. In the year 2009, what is the difference between the Value added (% of GDP) in Kazakhstan and Value added (% of GDP) in Luxembourg?
Provide a succinct answer. 27.37. In the year 2010, what is the difference between the Value added (% of GDP) in North America and Value added (% of GDP) in Cameroon?
Provide a succinct answer. -9.04. In the year 2010, what is the difference between the Value added (% of GDP) of North America and Value added (% of GDP) of Kazakhstan?
Provide a short and direct response. -22.02. In the year 2010, what is the difference between the Value added (% of GDP) of North America and Value added (% of GDP) of Luxembourg?
Make the answer very short. 7.99. In the year 2010, what is the difference between the Value added (% of GDP) of Cameroon and Value added (% of GDP) of Kazakhstan?
Offer a very short reply. -12.98. In the year 2010, what is the difference between the Value added (% of GDP) in Cameroon and Value added (% of GDP) in Luxembourg?
Your response must be concise. 17.03. In the year 2010, what is the difference between the Value added (% of GDP) in Kazakhstan and Value added (% of GDP) in Luxembourg?
Offer a terse response. 30.01. In the year 2011, what is the difference between the Value added (% of GDP) of North America and Value added (% of GDP) of Cameroon?
Your answer should be very brief. -9.03. In the year 2011, what is the difference between the Value added (% of GDP) of North America and Value added (% of GDP) of Kazakhstan?
Keep it short and to the point. -20.33. In the year 2011, what is the difference between the Value added (% of GDP) in North America and Value added (% of GDP) in Luxembourg?
Make the answer very short. 7.68. In the year 2011, what is the difference between the Value added (% of GDP) of Cameroon and Value added (% of GDP) of Kazakhstan?
Offer a very short reply. -11.3. In the year 2011, what is the difference between the Value added (% of GDP) of Cameroon and Value added (% of GDP) of Luxembourg?
Give a very brief answer. 16.7. In the year 2011, what is the difference between the Value added (% of GDP) in Kazakhstan and Value added (% of GDP) in Luxembourg?
Your response must be concise. 28.01. In the year 2012, what is the difference between the Value added (% of GDP) of North America and Value added (% of GDP) of Cameroon?
Make the answer very short. -9.68. In the year 2012, what is the difference between the Value added (% of GDP) in North America and Value added (% of GDP) in Kazakhstan?
Your answer should be compact. -18.94. In the year 2012, what is the difference between the Value added (% of GDP) of North America and Value added (% of GDP) of Luxembourg?
Offer a terse response. 8.33. In the year 2012, what is the difference between the Value added (% of GDP) in Cameroon and Value added (% of GDP) in Kazakhstan?
Ensure brevity in your answer.  -9.26. In the year 2012, what is the difference between the Value added (% of GDP) in Cameroon and Value added (% of GDP) in Luxembourg?
Offer a terse response. 18.02. In the year 2012, what is the difference between the Value added (% of GDP) of Kazakhstan and Value added (% of GDP) of Luxembourg?
Your response must be concise. 27.27. What is the ratio of the Value added (% of GDP) in North America in 2006 to that in 2007?
Provide a short and direct response. 0.98. What is the ratio of the Value added (% of GDP) in Cameroon in 2006 to that in 2007?
Keep it short and to the point. 1.11. What is the ratio of the Value added (% of GDP) of Kazakhstan in 2006 to that in 2007?
Ensure brevity in your answer.  1.04. What is the ratio of the Value added (% of GDP) in Luxembourg in 2006 to that in 2007?
Your response must be concise. 0.92. What is the ratio of the Value added (% of GDP) in North America in 2006 to that in 2008?
Make the answer very short. 1. What is the ratio of the Value added (% of GDP) in Cameroon in 2006 to that in 2008?
Offer a terse response. 1.15. What is the ratio of the Value added (% of GDP) in Kazakhstan in 2006 to that in 2008?
Offer a very short reply. 0.97. What is the ratio of the Value added (% of GDP) in North America in 2006 to that in 2009?
Make the answer very short. 1.09. What is the ratio of the Value added (% of GDP) in Cameroon in 2006 to that in 2009?
Ensure brevity in your answer.  1.11. What is the ratio of the Value added (% of GDP) of Kazakhstan in 2006 to that in 2009?
Your answer should be compact. 1.05. What is the ratio of the Value added (% of GDP) in Luxembourg in 2006 to that in 2009?
Make the answer very short. 1.19. What is the ratio of the Value added (% of GDP) of North America in 2006 to that in 2010?
Keep it short and to the point. 1.07. What is the ratio of the Value added (% of GDP) of Cameroon in 2006 to that in 2010?
Your response must be concise. 1.11. What is the ratio of the Value added (% of GDP) of Kazakhstan in 2006 to that in 2010?
Provide a short and direct response. 0.98. What is the ratio of the Value added (% of GDP) in Luxembourg in 2006 to that in 2010?
Keep it short and to the point. 1.19. What is the ratio of the Value added (% of GDP) of North America in 2006 to that in 2011?
Your response must be concise. 1.09. What is the ratio of the Value added (% of GDP) of Cameroon in 2006 to that in 2011?
Give a very brief answer. 1.12. What is the ratio of the Value added (% of GDP) of Kazakhstan in 2006 to that in 2011?
Provide a short and direct response. 1.03. What is the ratio of the Value added (% of GDP) in Luxembourg in 2006 to that in 2011?
Provide a succinct answer. 1.19. What is the ratio of the Value added (% of GDP) in North America in 2006 to that in 2012?
Give a very brief answer. 1.09. What is the ratio of the Value added (% of GDP) in Cameroon in 2006 to that in 2012?
Give a very brief answer. 1.1. What is the ratio of the Value added (% of GDP) of Kazakhstan in 2006 to that in 2012?
Your response must be concise. 1.07. What is the ratio of the Value added (% of GDP) in Luxembourg in 2006 to that in 2012?
Ensure brevity in your answer.  1.26. What is the ratio of the Value added (% of GDP) in North America in 2007 to that in 2008?
Provide a short and direct response. 1.02. What is the ratio of the Value added (% of GDP) of Cameroon in 2007 to that in 2008?
Your response must be concise. 1.03. What is the ratio of the Value added (% of GDP) of Kazakhstan in 2007 to that in 2008?
Make the answer very short. 0.94. What is the ratio of the Value added (% of GDP) in Luxembourg in 2007 to that in 2008?
Your answer should be compact. 1.09. What is the ratio of the Value added (% of GDP) of North America in 2007 to that in 2009?
Make the answer very short. 1.1. What is the ratio of the Value added (% of GDP) in Cameroon in 2007 to that in 2009?
Provide a succinct answer. 1. What is the ratio of the Value added (% of GDP) of Kazakhstan in 2007 to that in 2009?
Provide a succinct answer. 1.01. What is the ratio of the Value added (% of GDP) in Luxembourg in 2007 to that in 2009?
Keep it short and to the point. 1.29. What is the ratio of the Value added (% of GDP) in North America in 2007 to that in 2010?
Provide a succinct answer. 1.09. What is the ratio of the Value added (% of GDP) of Kazakhstan in 2007 to that in 2010?
Provide a short and direct response. 0.95. What is the ratio of the Value added (% of GDP) of Luxembourg in 2007 to that in 2010?
Keep it short and to the point. 1.29. What is the ratio of the Value added (% of GDP) of North America in 2007 to that in 2011?
Your answer should be very brief. 1.11. What is the ratio of the Value added (% of GDP) in Cameroon in 2007 to that in 2011?
Your response must be concise. 1.01. What is the ratio of the Value added (% of GDP) in Luxembourg in 2007 to that in 2011?
Your answer should be compact. 1.3. What is the ratio of the Value added (% of GDP) of North America in 2007 to that in 2012?
Make the answer very short. 1.11. What is the ratio of the Value added (% of GDP) in Cameroon in 2007 to that in 2012?
Offer a terse response. 0.99. What is the ratio of the Value added (% of GDP) in Kazakhstan in 2007 to that in 2012?
Offer a very short reply. 1.03. What is the ratio of the Value added (% of GDP) of Luxembourg in 2007 to that in 2012?
Your answer should be very brief. 1.36. What is the ratio of the Value added (% of GDP) in North America in 2008 to that in 2009?
Offer a terse response. 1.08. What is the ratio of the Value added (% of GDP) of Cameroon in 2008 to that in 2009?
Offer a very short reply. 0.97. What is the ratio of the Value added (% of GDP) in Kazakhstan in 2008 to that in 2009?
Provide a short and direct response. 1.07. What is the ratio of the Value added (% of GDP) in Luxembourg in 2008 to that in 2009?
Provide a succinct answer. 1.18. What is the ratio of the Value added (% of GDP) of North America in 2008 to that in 2010?
Provide a succinct answer. 1.07. What is the ratio of the Value added (% of GDP) of Cameroon in 2008 to that in 2010?
Offer a terse response. 0.97. What is the ratio of the Value added (% of GDP) of Kazakhstan in 2008 to that in 2010?
Offer a very short reply. 1.01. What is the ratio of the Value added (% of GDP) in Luxembourg in 2008 to that in 2010?
Offer a terse response. 1.19. What is the ratio of the Value added (% of GDP) in North America in 2008 to that in 2011?
Keep it short and to the point. 1.09. What is the ratio of the Value added (% of GDP) of Cameroon in 2008 to that in 2011?
Offer a terse response. 0.98. What is the ratio of the Value added (% of GDP) in Kazakhstan in 2008 to that in 2011?
Your answer should be compact. 1.06. What is the ratio of the Value added (% of GDP) in Luxembourg in 2008 to that in 2011?
Your answer should be compact. 1.19. What is the ratio of the Value added (% of GDP) of North America in 2008 to that in 2012?
Your answer should be compact. 1.09. What is the ratio of the Value added (% of GDP) of Cameroon in 2008 to that in 2012?
Your response must be concise. 0.96. What is the ratio of the Value added (% of GDP) of Kazakhstan in 2008 to that in 2012?
Keep it short and to the point. 1.1. What is the ratio of the Value added (% of GDP) in Luxembourg in 2008 to that in 2012?
Keep it short and to the point. 1.25. What is the ratio of the Value added (% of GDP) in North America in 2009 to that in 2010?
Make the answer very short. 0.99. What is the ratio of the Value added (% of GDP) of Kazakhstan in 2009 to that in 2010?
Ensure brevity in your answer.  0.94. What is the ratio of the Value added (% of GDP) in Luxembourg in 2009 to that in 2010?
Offer a very short reply. 1. What is the ratio of the Value added (% of GDP) in North America in 2009 to that in 2011?
Provide a succinct answer. 1. What is the ratio of the Value added (% of GDP) in Cameroon in 2009 to that in 2011?
Your answer should be compact. 1.01. What is the ratio of the Value added (% of GDP) of Kazakhstan in 2009 to that in 2011?
Ensure brevity in your answer.  0.99. What is the ratio of the Value added (% of GDP) of Luxembourg in 2009 to that in 2011?
Give a very brief answer. 1. What is the ratio of the Value added (% of GDP) in Cameroon in 2009 to that in 2012?
Provide a short and direct response. 0.99. What is the ratio of the Value added (% of GDP) in Luxembourg in 2009 to that in 2012?
Your answer should be compact. 1.06. What is the ratio of the Value added (% of GDP) in North America in 2010 to that in 2011?
Give a very brief answer. 1.02. What is the ratio of the Value added (% of GDP) of Cameroon in 2010 to that in 2011?
Offer a terse response. 1.01. What is the ratio of the Value added (% of GDP) of Kazakhstan in 2010 to that in 2011?
Provide a succinct answer. 1.05. What is the ratio of the Value added (% of GDP) in North America in 2010 to that in 2012?
Ensure brevity in your answer.  1.02. What is the ratio of the Value added (% of GDP) of Kazakhstan in 2010 to that in 2012?
Keep it short and to the point. 1.09. What is the ratio of the Value added (% of GDP) in Luxembourg in 2010 to that in 2012?
Keep it short and to the point. 1.05. What is the ratio of the Value added (% of GDP) in Cameroon in 2011 to that in 2012?
Give a very brief answer. 0.98. What is the ratio of the Value added (% of GDP) of Kazakhstan in 2011 to that in 2012?
Your answer should be very brief. 1.03. What is the ratio of the Value added (% of GDP) in Luxembourg in 2011 to that in 2012?
Keep it short and to the point. 1.05. What is the difference between the highest and the second highest Value added (% of GDP) in North America?
Your response must be concise. 0.4. What is the difference between the highest and the second highest Value added (% of GDP) of Cameroon?
Keep it short and to the point. 2.99. What is the difference between the highest and the second highest Value added (% of GDP) in Kazakhstan?
Your answer should be very brief. 0.39. What is the difference between the highest and the second highest Value added (% of GDP) in Luxembourg?
Provide a succinct answer. 1.33. What is the difference between the highest and the lowest Value added (% of GDP) in North America?
Provide a short and direct response. 2.21. What is the difference between the highest and the lowest Value added (% of GDP) in Cameroon?
Offer a terse response. 4.26. What is the difference between the highest and the lowest Value added (% of GDP) of Kazakhstan?
Offer a very short reply. 3.79. What is the difference between the highest and the lowest Value added (% of GDP) of Luxembourg?
Your answer should be very brief. 4.45. 